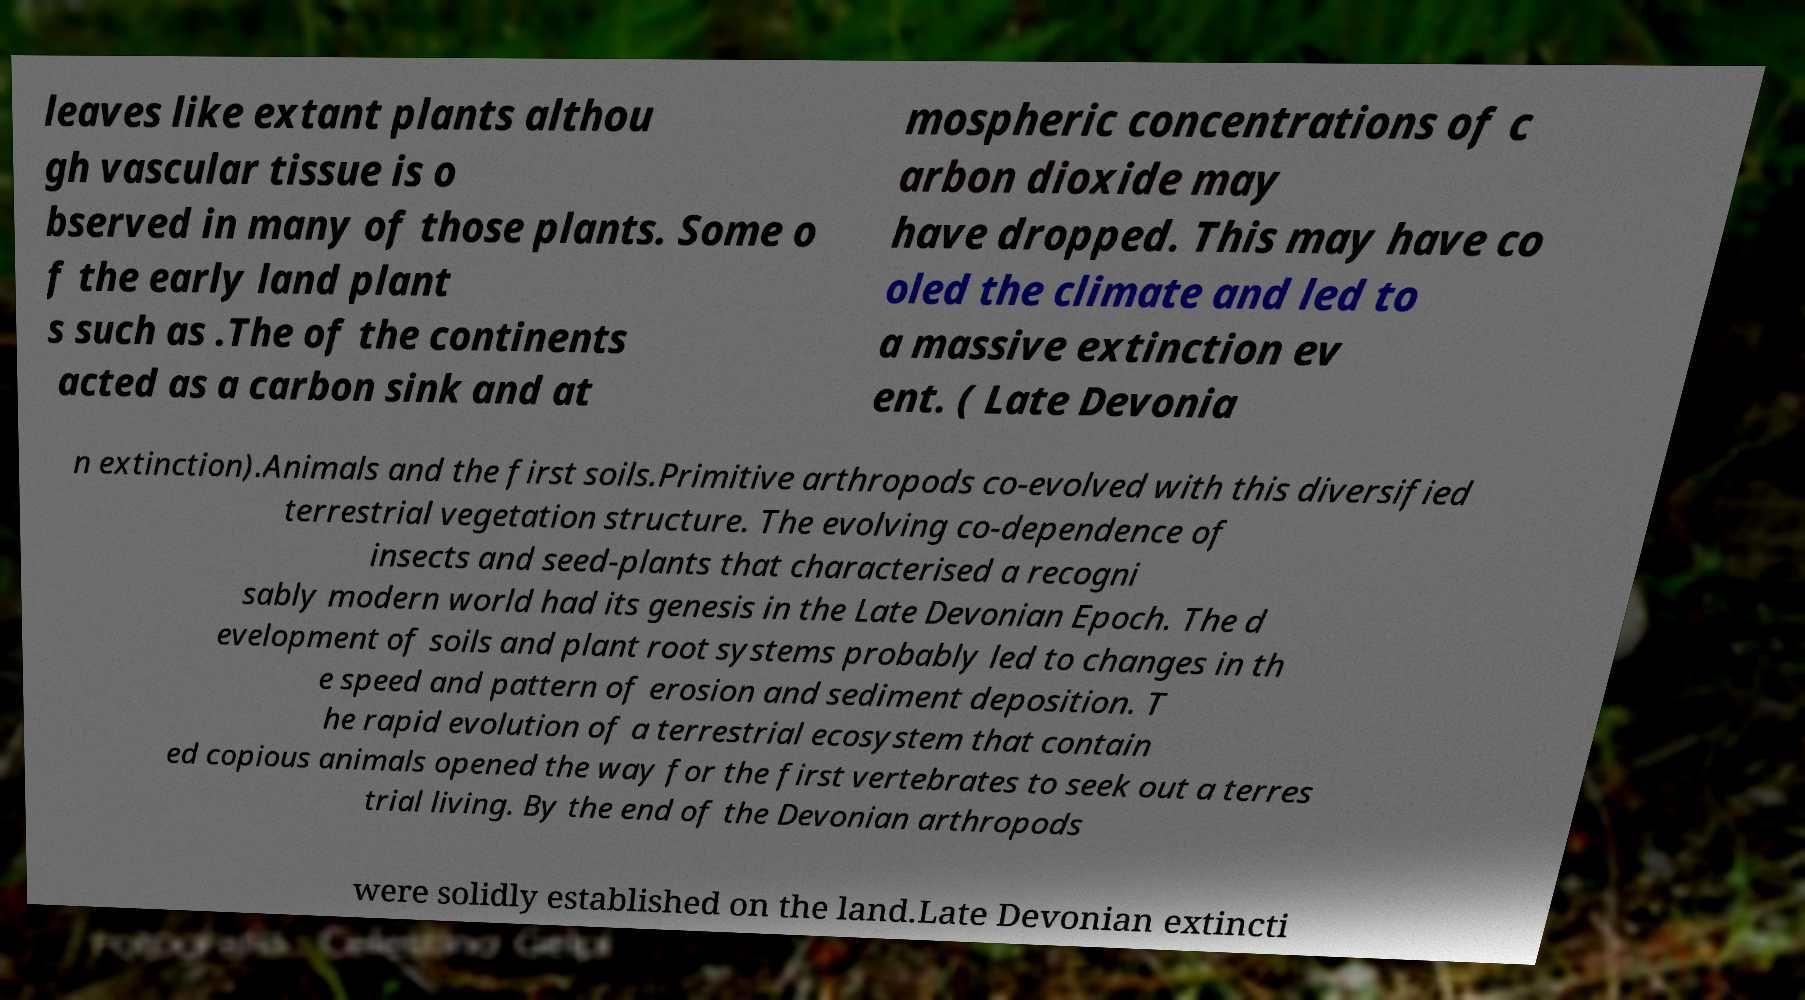I need the written content from this picture converted into text. Can you do that? leaves like extant plants althou gh vascular tissue is o bserved in many of those plants. Some o f the early land plant s such as .The of the continents acted as a carbon sink and at mospheric concentrations of c arbon dioxide may have dropped. This may have co oled the climate and led to a massive extinction ev ent. ( Late Devonia n extinction).Animals and the first soils.Primitive arthropods co-evolved with this diversified terrestrial vegetation structure. The evolving co-dependence of insects and seed-plants that characterised a recogni sably modern world had its genesis in the Late Devonian Epoch. The d evelopment of soils and plant root systems probably led to changes in th e speed and pattern of erosion and sediment deposition. T he rapid evolution of a terrestrial ecosystem that contain ed copious animals opened the way for the first vertebrates to seek out a terres trial living. By the end of the Devonian arthropods were solidly established on the land.Late Devonian extincti 